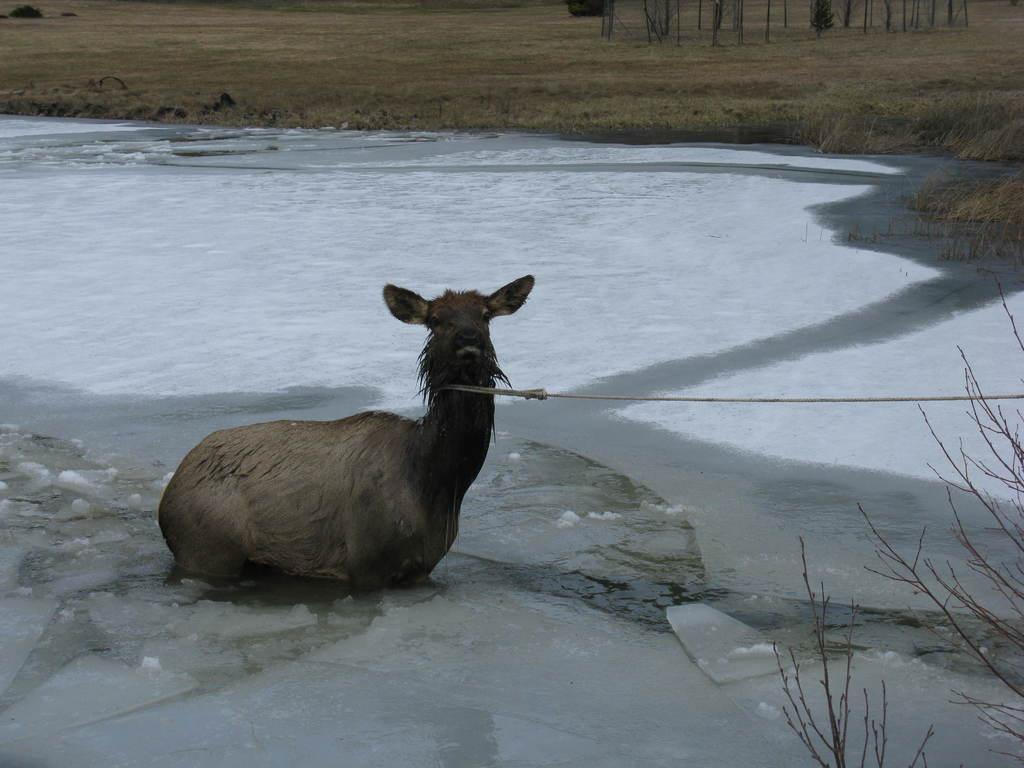Describe this image in one or two sentences. In the center of the image we can see animal sitting on the ground. On the right side of the image there is a tree. In the background we can see water, grass and trees. 